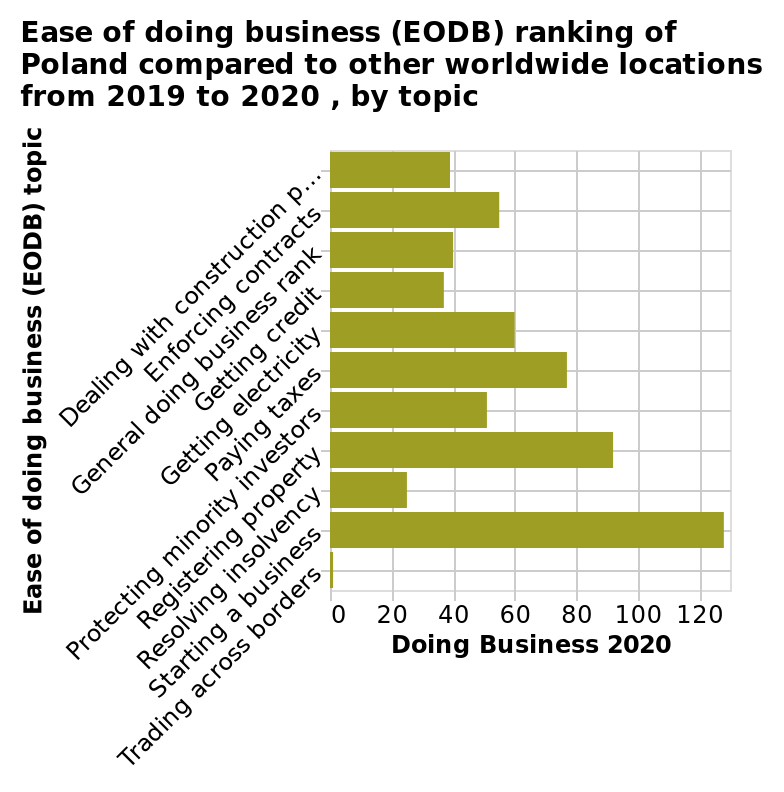<image>
Which aspect of business ranking is shown as the worst in Poland? Resolving insolvency. According to the figure, what is the difficulty level of starting a business in Poland? It is shown to be the easiest. What does the x-axis represent in the bar plot?  The x-axis represents the "Doing Business 2020" topic. 